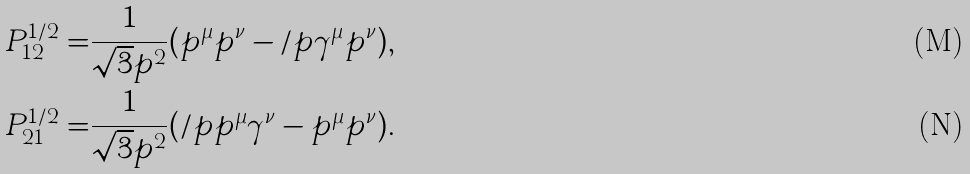Convert formula to latex. <formula><loc_0><loc_0><loc_500><loc_500>P ^ { 1 / 2 } _ { 1 2 } = & \frac { 1 } { \sqrt { 3 } p ^ { 2 } } ( p ^ { \mu } p ^ { \nu } - \slash p \gamma ^ { \mu } p ^ { \nu } ) , \\ P ^ { 1 / 2 } _ { 2 1 } = & \frac { 1 } { \sqrt { 3 } p ^ { 2 } } ( \slash p p ^ { \mu } \gamma ^ { \nu } - p ^ { \mu } p ^ { \nu } ) .</formula> 